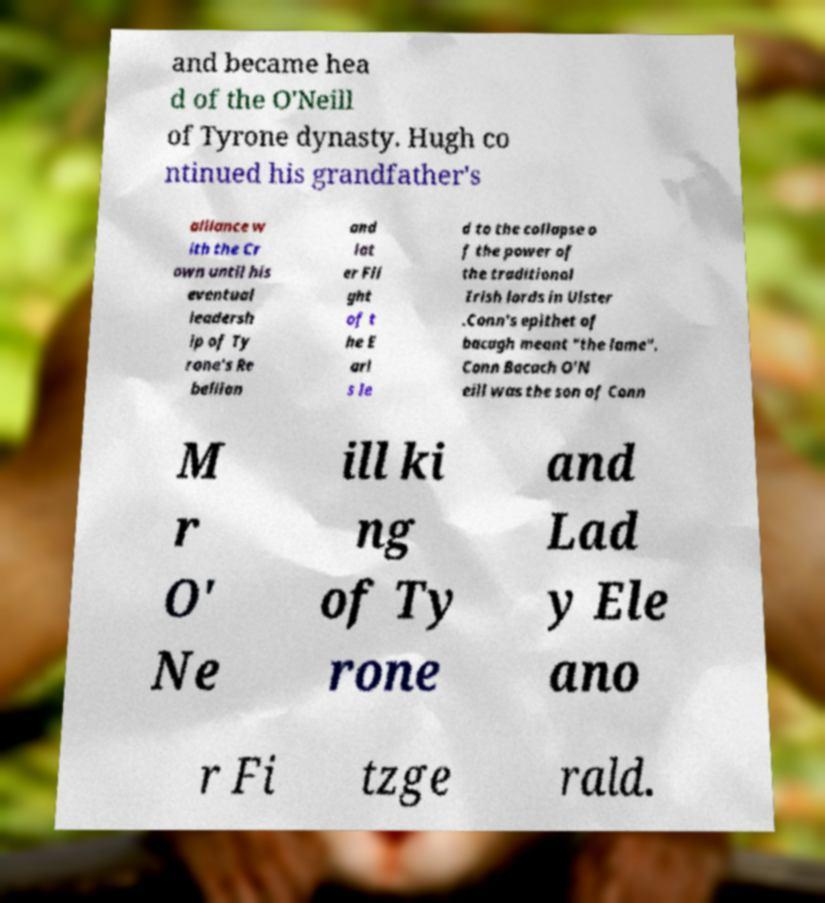Could you extract and type out the text from this image? and became hea d of the O'Neill of Tyrone dynasty. Hugh co ntinued his grandfather's alliance w ith the Cr own until his eventual leadersh ip of Ty rone's Re bellion and lat er Fli ght of t he E arl s le d to the collapse o f the power of the traditional Irish lords in Ulster .Conn's epithet of bacagh meant "the lame". Conn Bacach O'N eill was the son of Conn M r O' Ne ill ki ng of Ty rone and Lad y Ele ano r Fi tzge rald. 